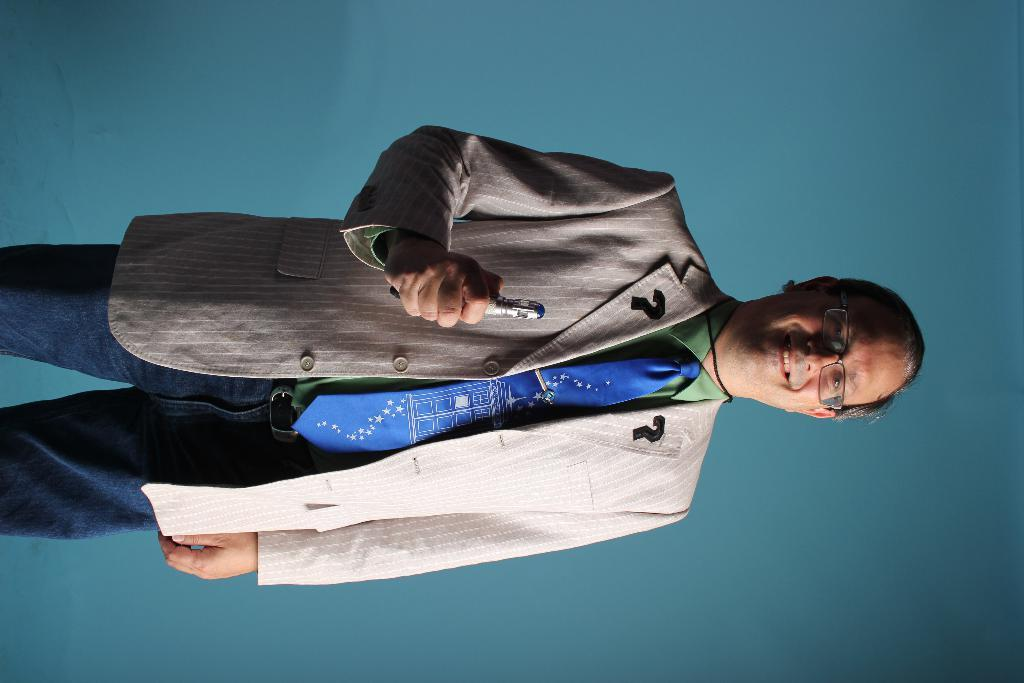Who is present in the image? There is a man in the image. What is the man doing in the image? The man is standing in the image. What is the man wearing in the image? The man is wearing a coat and a tie in the image. What is the man holding in the image? The man is holding a pen in the image. What can be seen in the background of the image? There is a wall in the background of the image. What type of stick can be seen in the man's hand in the image? There is no stick present in the man's hand in the image; he is holding a pen. 